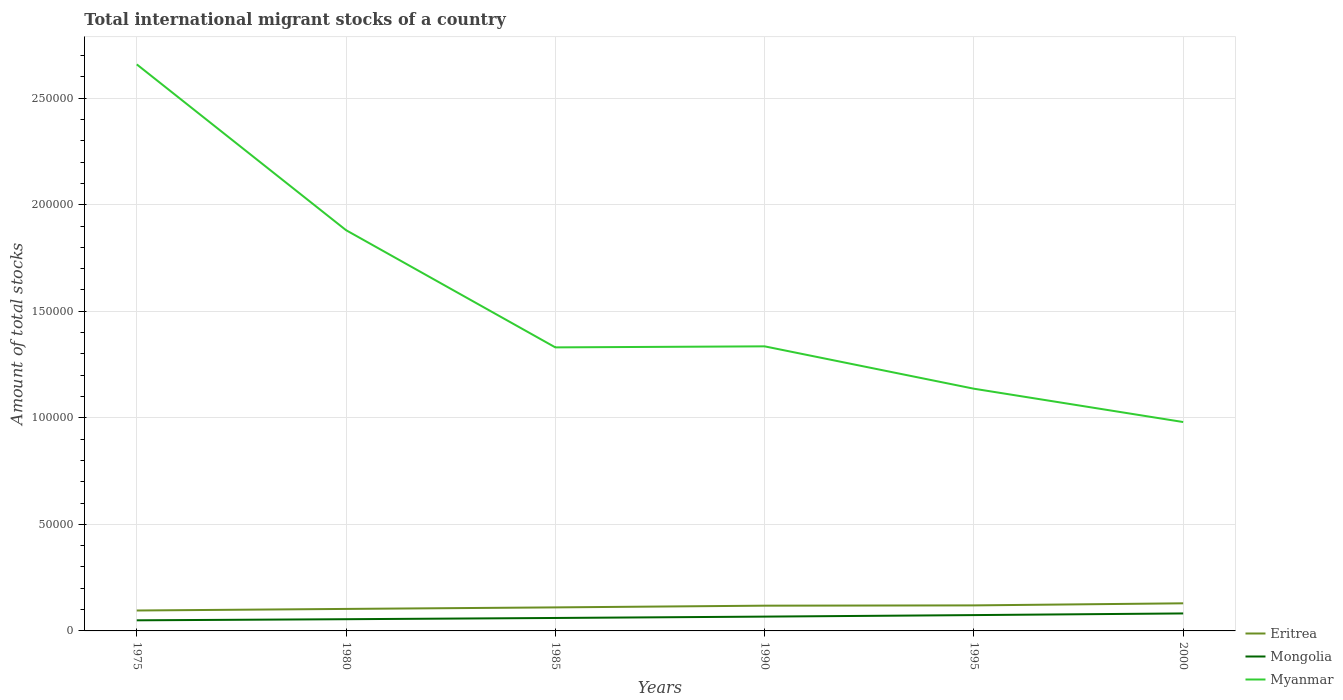How many different coloured lines are there?
Your answer should be compact. 3. Does the line corresponding to Mongolia intersect with the line corresponding to Eritrea?
Ensure brevity in your answer.  No. Is the number of lines equal to the number of legend labels?
Ensure brevity in your answer.  Yes. Across all years, what is the maximum amount of total stocks in in Eritrea?
Your response must be concise. 9585. In which year was the amount of total stocks in in Mongolia maximum?
Give a very brief answer. 1975. What is the total amount of total stocks in in Eritrea in the graph?
Your response must be concise. -1912. What is the difference between the highest and the second highest amount of total stocks in in Myanmar?
Your response must be concise. 1.68e+05. How many lines are there?
Your response must be concise. 3. What is the difference between two consecutive major ticks on the Y-axis?
Offer a very short reply. 5.00e+04. Does the graph contain grids?
Make the answer very short. Yes. Where does the legend appear in the graph?
Make the answer very short. Bottom right. How many legend labels are there?
Your response must be concise. 3. What is the title of the graph?
Keep it short and to the point. Total international migrant stocks of a country. Does "Yemen, Rep." appear as one of the legend labels in the graph?
Your response must be concise. No. What is the label or title of the X-axis?
Provide a succinct answer. Years. What is the label or title of the Y-axis?
Offer a very short reply. Amount of total stocks. What is the Amount of total stocks of Eritrea in 1975?
Provide a short and direct response. 9585. What is the Amount of total stocks in Mongolia in 1975?
Provide a succinct answer. 4975. What is the Amount of total stocks in Myanmar in 1975?
Give a very brief answer. 2.66e+05. What is the Amount of total stocks in Eritrea in 1980?
Offer a very short reply. 1.03e+04. What is the Amount of total stocks of Mongolia in 1980?
Keep it short and to the point. 5499. What is the Amount of total stocks of Myanmar in 1980?
Make the answer very short. 1.88e+05. What is the Amount of total stocks of Eritrea in 1985?
Provide a succinct answer. 1.10e+04. What is the Amount of total stocks of Mongolia in 1985?
Keep it short and to the point. 6078. What is the Amount of total stocks of Myanmar in 1985?
Keep it short and to the point. 1.33e+05. What is the Amount of total stocks of Eritrea in 1990?
Your answer should be compact. 1.18e+04. What is the Amount of total stocks in Mongolia in 1990?
Provide a succinct answer. 6718. What is the Amount of total stocks in Myanmar in 1990?
Your answer should be compact. 1.34e+05. What is the Amount of total stocks of Eritrea in 1995?
Keep it short and to the point. 1.20e+04. What is the Amount of total stocks of Mongolia in 1995?
Make the answer very short. 7425. What is the Amount of total stocks of Myanmar in 1995?
Make the answer very short. 1.14e+05. What is the Amount of total stocks of Eritrea in 2000?
Keep it short and to the point. 1.30e+04. What is the Amount of total stocks in Mongolia in 2000?
Your answer should be very brief. 8206. What is the Amount of total stocks of Myanmar in 2000?
Make the answer very short. 9.80e+04. Across all years, what is the maximum Amount of total stocks of Eritrea?
Provide a succinct answer. 1.30e+04. Across all years, what is the maximum Amount of total stocks in Mongolia?
Your answer should be compact. 8206. Across all years, what is the maximum Amount of total stocks of Myanmar?
Give a very brief answer. 2.66e+05. Across all years, what is the minimum Amount of total stocks of Eritrea?
Offer a very short reply. 9585. Across all years, what is the minimum Amount of total stocks in Mongolia?
Ensure brevity in your answer.  4975. Across all years, what is the minimum Amount of total stocks of Myanmar?
Offer a terse response. 9.80e+04. What is the total Amount of total stocks of Eritrea in the graph?
Your response must be concise. 6.77e+04. What is the total Amount of total stocks of Mongolia in the graph?
Your answer should be very brief. 3.89e+04. What is the total Amount of total stocks in Myanmar in the graph?
Your answer should be compact. 9.32e+05. What is the difference between the Amount of total stocks of Eritrea in 1975 and that in 1980?
Provide a succinct answer. -738. What is the difference between the Amount of total stocks in Mongolia in 1975 and that in 1980?
Provide a succinct answer. -524. What is the difference between the Amount of total stocks of Myanmar in 1975 and that in 1980?
Give a very brief answer. 7.78e+04. What is the difference between the Amount of total stocks in Eritrea in 1975 and that in 1985?
Your response must be concise. -1455. What is the difference between the Amount of total stocks of Mongolia in 1975 and that in 1985?
Offer a very short reply. -1103. What is the difference between the Amount of total stocks of Myanmar in 1975 and that in 1985?
Keep it short and to the point. 1.33e+05. What is the difference between the Amount of total stocks in Eritrea in 1975 and that in 1990?
Your response must be concise. -2263. What is the difference between the Amount of total stocks of Mongolia in 1975 and that in 1990?
Your response must be concise. -1743. What is the difference between the Amount of total stocks in Myanmar in 1975 and that in 1990?
Your answer should be very brief. 1.32e+05. What is the difference between the Amount of total stocks of Eritrea in 1975 and that in 1995?
Give a very brief answer. -2393. What is the difference between the Amount of total stocks in Mongolia in 1975 and that in 1995?
Keep it short and to the point. -2450. What is the difference between the Amount of total stocks of Myanmar in 1975 and that in 1995?
Offer a very short reply. 1.52e+05. What is the difference between the Amount of total stocks of Eritrea in 1975 and that in 2000?
Ensure brevity in your answer.  -3367. What is the difference between the Amount of total stocks in Mongolia in 1975 and that in 2000?
Make the answer very short. -3231. What is the difference between the Amount of total stocks of Myanmar in 1975 and that in 2000?
Offer a very short reply. 1.68e+05. What is the difference between the Amount of total stocks of Eritrea in 1980 and that in 1985?
Your answer should be very brief. -717. What is the difference between the Amount of total stocks of Mongolia in 1980 and that in 1985?
Keep it short and to the point. -579. What is the difference between the Amount of total stocks in Myanmar in 1980 and that in 1985?
Give a very brief answer. 5.50e+04. What is the difference between the Amount of total stocks of Eritrea in 1980 and that in 1990?
Give a very brief answer. -1525. What is the difference between the Amount of total stocks of Mongolia in 1980 and that in 1990?
Your answer should be compact. -1219. What is the difference between the Amount of total stocks of Myanmar in 1980 and that in 1990?
Your answer should be compact. 5.45e+04. What is the difference between the Amount of total stocks in Eritrea in 1980 and that in 1995?
Ensure brevity in your answer.  -1655. What is the difference between the Amount of total stocks of Mongolia in 1980 and that in 1995?
Provide a short and direct response. -1926. What is the difference between the Amount of total stocks of Myanmar in 1980 and that in 1995?
Provide a short and direct response. 7.44e+04. What is the difference between the Amount of total stocks in Eritrea in 1980 and that in 2000?
Keep it short and to the point. -2629. What is the difference between the Amount of total stocks in Mongolia in 1980 and that in 2000?
Offer a terse response. -2707. What is the difference between the Amount of total stocks in Myanmar in 1980 and that in 2000?
Offer a very short reply. 9.00e+04. What is the difference between the Amount of total stocks in Eritrea in 1985 and that in 1990?
Keep it short and to the point. -808. What is the difference between the Amount of total stocks in Mongolia in 1985 and that in 1990?
Give a very brief answer. -640. What is the difference between the Amount of total stocks in Myanmar in 1985 and that in 1990?
Ensure brevity in your answer.  -485. What is the difference between the Amount of total stocks of Eritrea in 1985 and that in 1995?
Your answer should be very brief. -938. What is the difference between the Amount of total stocks in Mongolia in 1985 and that in 1995?
Offer a very short reply. -1347. What is the difference between the Amount of total stocks in Myanmar in 1985 and that in 1995?
Offer a very short reply. 1.94e+04. What is the difference between the Amount of total stocks of Eritrea in 1985 and that in 2000?
Offer a terse response. -1912. What is the difference between the Amount of total stocks of Mongolia in 1985 and that in 2000?
Your answer should be compact. -2128. What is the difference between the Amount of total stocks in Myanmar in 1985 and that in 2000?
Your response must be concise. 3.50e+04. What is the difference between the Amount of total stocks of Eritrea in 1990 and that in 1995?
Ensure brevity in your answer.  -130. What is the difference between the Amount of total stocks of Mongolia in 1990 and that in 1995?
Your answer should be very brief. -707. What is the difference between the Amount of total stocks of Myanmar in 1990 and that in 1995?
Your response must be concise. 1.99e+04. What is the difference between the Amount of total stocks in Eritrea in 1990 and that in 2000?
Ensure brevity in your answer.  -1104. What is the difference between the Amount of total stocks in Mongolia in 1990 and that in 2000?
Offer a terse response. -1488. What is the difference between the Amount of total stocks in Myanmar in 1990 and that in 2000?
Offer a terse response. 3.55e+04. What is the difference between the Amount of total stocks in Eritrea in 1995 and that in 2000?
Provide a succinct answer. -974. What is the difference between the Amount of total stocks of Mongolia in 1995 and that in 2000?
Your response must be concise. -781. What is the difference between the Amount of total stocks in Myanmar in 1995 and that in 2000?
Ensure brevity in your answer.  1.56e+04. What is the difference between the Amount of total stocks of Eritrea in 1975 and the Amount of total stocks of Mongolia in 1980?
Your answer should be very brief. 4086. What is the difference between the Amount of total stocks of Eritrea in 1975 and the Amount of total stocks of Myanmar in 1980?
Your answer should be very brief. -1.78e+05. What is the difference between the Amount of total stocks of Mongolia in 1975 and the Amount of total stocks of Myanmar in 1980?
Provide a succinct answer. -1.83e+05. What is the difference between the Amount of total stocks in Eritrea in 1975 and the Amount of total stocks in Mongolia in 1985?
Provide a short and direct response. 3507. What is the difference between the Amount of total stocks in Eritrea in 1975 and the Amount of total stocks in Myanmar in 1985?
Keep it short and to the point. -1.23e+05. What is the difference between the Amount of total stocks in Mongolia in 1975 and the Amount of total stocks in Myanmar in 1985?
Your answer should be very brief. -1.28e+05. What is the difference between the Amount of total stocks in Eritrea in 1975 and the Amount of total stocks in Mongolia in 1990?
Offer a terse response. 2867. What is the difference between the Amount of total stocks in Eritrea in 1975 and the Amount of total stocks in Myanmar in 1990?
Your answer should be very brief. -1.24e+05. What is the difference between the Amount of total stocks in Mongolia in 1975 and the Amount of total stocks in Myanmar in 1990?
Provide a succinct answer. -1.29e+05. What is the difference between the Amount of total stocks of Eritrea in 1975 and the Amount of total stocks of Mongolia in 1995?
Give a very brief answer. 2160. What is the difference between the Amount of total stocks of Eritrea in 1975 and the Amount of total stocks of Myanmar in 1995?
Give a very brief answer. -1.04e+05. What is the difference between the Amount of total stocks in Mongolia in 1975 and the Amount of total stocks in Myanmar in 1995?
Your answer should be compact. -1.09e+05. What is the difference between the Amount of total stocks of Eritrea in 1975 and the Amount of total stocks of Mongolia in 2000?
Keep it short and to the point. 1379. What is the difference between the Amount of total stocks in Eritrea in 1975 and the Amount of total stocks in Myanmar in 2000?
Make the answer very short. -8.84e+04. What is the difference between the Amount of total stocks in Mongolia in 1975 and the Amount of total stocks in Myanmar in 2000?
Your answer should be compact. -9.30e+04. What is the difference between the Amount of total stocks of Eritrea in 1980 and the Amount of total stocks of Mongolia in 1985?
Give a very brief answer. 4245. What is the difference between the Amount of total stocks of Eritrea in 1980 and the Amount of total stocks of Myanmar in 1985?
Ensure brevity in your answer.  -1.23e+05. What is the difference between the Amount of total stocks of Mongolia in 1980 and the Amount of total stocks of Myanmar in 1985?
Your answer should be very brief. -1.28e+05. What is the difference between the Amount of total stocks of Eritrea in 1980 and the Amount of total stocks of Mongolia in 1990?
Give a very brief answer. 3605. What is the difference between the Amount of total stocks in Eritrea in 1980 and the Amount of total stocks in Myanmar in 1990?
Provide a short and direct response. -1.23e+05. What is the difference between the Amount of total stocks of Mongolia in 1980 and the Amount of total stocks of Myanmar in 1990?
Offer a terse response. -1.28e+05. What is the difference between the Amount of total stocks in Eritrea in 1980 and the Amount of total stocks in Mongolia in 1995?
Your answer should be compact. 2898. What is the difference between the Amount of total stocks of Eritrea in 1980 and the Amount of total stocks of Myanmar in 1995?
Your response must be concise. -1.03e+05. What is the difference between the Amount of total stocks of Mongolia in 1980 and the Amount of total stocks of Myanmar in 1995?
Make the answer very short. -1.08e+05. What is the difference between the Amount of total stocks in Eritrea in 1980 and the Amount of total stocks in Mongolia in 2000?
Offer a terse response. 2117. What is the difference between the Amount of total stocks of Eritrea in 1980 and the Amount of total stocks of Myanmar in 2000?
Your response must be concise. -8.77e+04. What is the difference between the Amount of total stocks of Mongolia in 1980 and the Amount of total stocks of Myanmar in 2000?
Provide a succinct answer. -9.25e+04. What is the difference between the Amount of total stocks in Eritrea in 1985 and the Amount of total stocks in Mongolia in 1990?
Make the answer very short. 4322. What is the difference between the Amount of total stocks of Eritrea in 1985 and the Amount of total stocks of Myanmar in 1990?
Your answer should be compact. -1.22e+05. What is the difference between the Amount of total stocks in Mongolia in 1985 and the Amount of total stocks in Myanmar in 1990?
Ensure brevity in your answer.  -1.27e+05. What is the difference between the Amount of total stocks in Eritrea in 1985 and the Amount of total stocks in Mongolia in 1995?
Offer a terse response. 3615. What is the difference between the Amount of total stocks of Eritrea in 1985 and the Amount of total stocks of Myanmar in 1995?
Give a very brief answer. -1.03e+05. What is the difference between the Amount of total stocks of Mongolia in 1985 and the Amount of total stocks of Myanmar in 1995?
Keep it short and to the point. -1.08e+05. What is the difference between the Amount of total stocks in Eritrea in 1985 and the Amount of total stocks in Mongolia in 2000?
Your answer should be very brief. 2834. What is the difference between the Amount of total stocks of Eritrea in 1985 and the Amount of total stocks of Myanmar in 2000?
Your response must be concise. -8.70e+04. What is the difference between the Amount of total stocks in Mongolia in 1985 and the Amount of total stocks in Myanmar in 2000?
Give a very brief answer. -9.19e+04. What is the difference between the Amount of total stocks of Eritrea in 1990 and the Amount of total stocks of Mongolia in 1995?
Your answer should be very brief. 4423. What is the difference between the Amount of total stocks in Eritrea in 1990 and the Amount of total stocks in Myanmar in 1995?
Provide a short and direct response. -1.02e+05. What is the difference between the Amount of total stocks in Mongolia in 1990 and the Amount of total stocks in Myanmar in 1995?
Provide a succinct answer. -1.07e+05. What is the difference between the Amount of total stocks of Eritrea in 1990 and the Amount of total stocks of Mongolia in 2000?
Ensure brevity in your answer.  3642. What is the difference between the Amount of total stocks of Eritrea in 1990 and the Amount of total stocks of Myanmar in 2000?
Your response must be concise. -8.62e+04. What is the difference between the Amount of total stocks of Mongolia in 1990 and the Amount of total stocks of Myanmar in 2000?
Provide a short and direct response. -9.13e+04. What is the difference between the Amount of total stocks of Eritrea in 1995 and the Amount of total stocks of Mongolia in 2000?
Your answer should be very brief. 3772. What is the difference between the Amount of total stocks in Eritrea in 1995 and the Amount of total stocks in Myanmar in 2000?
Your response must be concise. -8.60e+04. What is the difference between the Amount of total stocks in Mongolia in 1995 and the Amount of total stocks in Myanmar in 2000?
Provide a short and direct response. -9.06e+04. What is the average Amount of total stocks of Eritrea per year?
Give a very brief answer. 1.13e+04. What is the average Amount of total stocks of Mongolia per year?
Make the answer very short. 6483.5. What is the average Amount of total stocks of Myanmar per year?
Make the answer very short. 1.55e+05. In the year 1975, what is the difference between the Amount of total stocks of Eritrea and Amount of total stocks of Mongolia?
Offer a very short reply. 4610. In the year 1975, what is the difference between the Amount of total stocks of Eritrea and Amount of total stocks of Myanmar?
Provide a short and direct response. -2.56e+05. In the year 1975, what is the difference between the Amount of total stocks of Mongolia and Amount of total stocks of Myanmar?
Ensure brevity in your answer.  -2.61e+05. In the year 1980, what is the difference between the Amount of total stocks in Eritrea and Amount of total stocks in Mongolia?
Make the answer very short. 4824. In the year 1980, what is the difference between the Amount of total stocks in Eritrea and Amount of total stocks in Myanmar?
Give a very brief answer. -1.78e+05. In the year 1980, what is the difference between the Amount of total stocks in Mongolia and Amount of total stocks in Myanmar?
Ensure brevity in your answer.  -1.83e+05. In the year 1985, what is the difference between the Amount of total stocks in Eritrea and Amount of total stocks in Mongolia?
Make the answer very short. 4962. In the year 1985, what is the difference between the Amount of total stocks in Eritrea and Amount of total stocks in Myanmar?
Your answer should be compact. -1.22e+05. In the year 1985, what is the difference between the Amount of total stocks of Mongolia and Amount of total stocks of Myanmar?
Offer a terse response. -1.27e+05. In the year 1990, what is the difference between the Amount of total stocks in Eritrea and Amount of total stocks in Mongolia?
Provide a short and direct response. 5130. In the year 1990, what is the difference between the Amount of total stocks of Eritrea and Amount of total stocks of Myanmar?
Offer a very short reply. -1.22e+05. In the year 1990, what is the difference between the Amount of total stocks of Mongolia and Amount of total stocks of Myanmar?
Offer a terse response. -1.27e+05. In the year 1995, what is the difference between the Amount of total stocks of Eritrea and Amount of total stocks of Mongolia?
Offer a terse response. 4553. In the year 1995, what is the difference between the Amount of total stocks of Eritrea and Amount of total stocks of Myanmar?
Give a very brief answer. -1.02e+05. In the year 1995, what is the difference between the Amount of total stocks in Mongolia and Amount of total stocks in Myanmar?
Make the answer very short. -1.06e+05. In the year 2000, what is the difference between the Amount of total stocks of Eritrea and Amount of total stocks of Mongolia?
Your answer should be very brief. 4746. In the year 2000, what is the difference between the Amount of total stocks of Eritrea and Amount of total stocks of Myanmar?
Keep it short and to the point. -8.51e+04. In the year 2000, what is the difference between the Amount of total stocks of Mongolia and Amount of total stocks of Myanmar?
Provide a short and direct response. -8.98e+04. What is the ratio of the Amount of total stocks of Eritrea in 1975 to that in 1980?
Your response must be concise. 0.93. What is the ratio of the Amount of total stocks in Mongolia in 1975 to that in 1980?
Your answer should be very brief. 0.9. What is the ratio of the Amount of total stocks of Myanmar in 1975 to that in 1980?
Your answer should be compact. 1.41. What is the ratio of the Amount of total stocks in Eritrea in 1975 to that in 1985?
Your answer should be compact. 0.87. What is the ratio of the Amount of total stocks in Mongolia in 1975 to that in 1985?
Offer a very short reply. 0.82. What is the ratio of the Amount of total stocks of Myanmar in 1975 to that in 1985?
Ensure brevity in your answer.  2. What is the ratio of the Amount of total stocks in Eritrea in 1975 to that in 1990?
Your answer should be very brief. 0.81. What is the ratio of the Amount of total stocks of Mongolia in 1975 to that in 1990?
Offer a very short reply. 0.74. What is the ratio of the Amount of total stocks of Myanmar in 1975 to that in 1990?
Ensure brevity in your answer.  1.99. What is the ratio of the Amount of total stocks of Eritrea in 1975 to that in 1995?
Your response must be concise. 0.8. What is the ratio of the Amount of total stocks of Mongolia in 1975 to that in 1995?
Offer a terse response. 0.67. What is the ratio of the Amount of total stocks of Myanmar in 1975 to that in 1995?
Offer a terse response. 2.34. What is the ratio of the Amount of total stocks of Eritrea in 1975 to that in 2000?
Give a very brief answer. 0.74. What is the ratio of the Amount of total stocks in Mongolia in 1975 to that in 2000?
Keep it short and to the point. 0.61. What is the ratio of the Amount of total stocks of Myanmar in 1975 to that in 2000?
Your response must be concise. 2.71. What is the ratio of the Amount of total stocks of Eritrea in 1980 to that in 1985?
Make the answer very short. 0.94. What is the ratio of the Amount of total stocks in Mongolia in 1980 to that in 1985?
Give a very brief answer. 0.9. What is the ratio of the Amount of total stocks in Myanmar in 1980 to that in 1985?
Keep it short and to the point. 1.41. What is the ratio of the Amount of total stocks in Eritrea in 1980 to that in 1990?
Give a very brief answer. 0.87. What is the ratio of the Amount of total stocks of Mongolia in 1980 to that in 1990?
Offer a terse response. 0.82. What is the ratio of the Amount of total stocks of Myanmar in 1980 to that in 1990?
Make the answer very short. 1.41. What is the ratio of the Amount of total stocks of Eritrea in 1980 to that in 1995?
Keep it short and to the point. 0.86. What is the ratio of the Amount of total stocks of Mongolia in 1980 to that in 1995?
Offer a terse response. 0.74. What is the ratio of the Amount of total stocks of Myanmar in 1980 to that in 1995?
Make the answer very short. 1.65. What is the ratio of the Amount of total stocks of Eritrea in 1980 to that in 2000?
Your response must be concise. 0.8. What is the ratio of the Amount of total stocks in Mongolia in 1980 to that in 2000?
Your answer should be compact. 0.67. What is the ratio of the Amount of total stocks of Myanmar in 1980 to that in 2000?
Your answer should be compact. 1.92. What is the ratio of the Amount of total stocks of Eritrea in 1985 to that in 1990?
Provide a succinct answer. 0.93. What is the ratio of the Amount of total stocks of Mongolia in 1985 to that in 1990?
Offer a terse response. 0.9. What is the ratio of the Amount of total stocks of Myanmar in 1985 to that in 1990?
Your answer should be very brief. 1. What is the ratio of the Amount of total stocks in Eritrea in 1985 to that in 1995?
Offer a terse response. 0.92. What is the ratio of the Amount of total stocks of Mongolia in 1985 to that in 1995?
Make the answer very short. 0.82. What is the ratio of the Amount of total stocks in Myanmar in 1985 to that in 1995?
Make the answer very short. 1.17. What is the ratio of the Amount of total stocks in Eritrea in 1985 to that in 2000?
Your answer should be compact. 0.85. What is the ratio of the Amount of total stocks in Mongolia in 1985 to that in 2000?
Provide a short and direct response. 0.74. What is the ratio of the Amount of total stocks in Myanmar in 1985 to that in 2000?
Ensure brevity in your answer.  1.36. What is the ratio of the Amount of total stocks in Eritrea in 1990 to that in 1995?
Your answer should be compact. 0.99. What is the ratio of the Amount of total stocks of Mongolia in 1990 to that in 1995?
Offer a terse response. 0.9. What is the ratio of the Amount of total stocks of Myanmar in 1990 to that in 1995?
Keep it short and to the point. 1.17. What is the ratio of the Amount of total stocks of Eritrea in 1990 to that in 2000?
Make the answer very short. 0.91. What is the ratio of the Amount of total stocks in Mongolia in 1990 to that in 2000?
Offer a very short reply. 0.82. What is the ratio of the Amount of total stocks of Myanmar in 1990 to that in 2000?
Ensure brevity in your answer.  1.36. What is the ratio of the Amount of total stocks in Eritrea in 1995 to that in 2000?
Your answer should be very brief. 0.92. What is the ratio of the Amount of total stocks of Mongolia in 1995 to that in 2000?
Provide a succinct answer. 0.9. What is the ratio of the Amount of total stocks of Myanmar in 1995 to that in 2000?
Make the answer very short. 1.16. What is the difference between the highest and the second highest Amount of total stocks in Eritrea?
Ensure brevity in your answer.  974. What is the difference between the highest and the second highest Amount of total stocks in Mongolia?
Your answer should be very brief. 781. What is the difference between the highest and the second highest Amount of total stocks in Myanmar?
Offer a very short reply. 7.78e+04. What is the difference between the highest and the lowest Amount of total stocks in Eritrea?
Provide a short and direct response. 3367. What is the difference between the highest and the lowest Amount of total stocks of Mongolia?
Ensure brevity in your answer.  3231. What is the difference between the highest and the lowest Amount of total stocks in Myanmar?
Keep it short and to the point. 1.68e+05. 